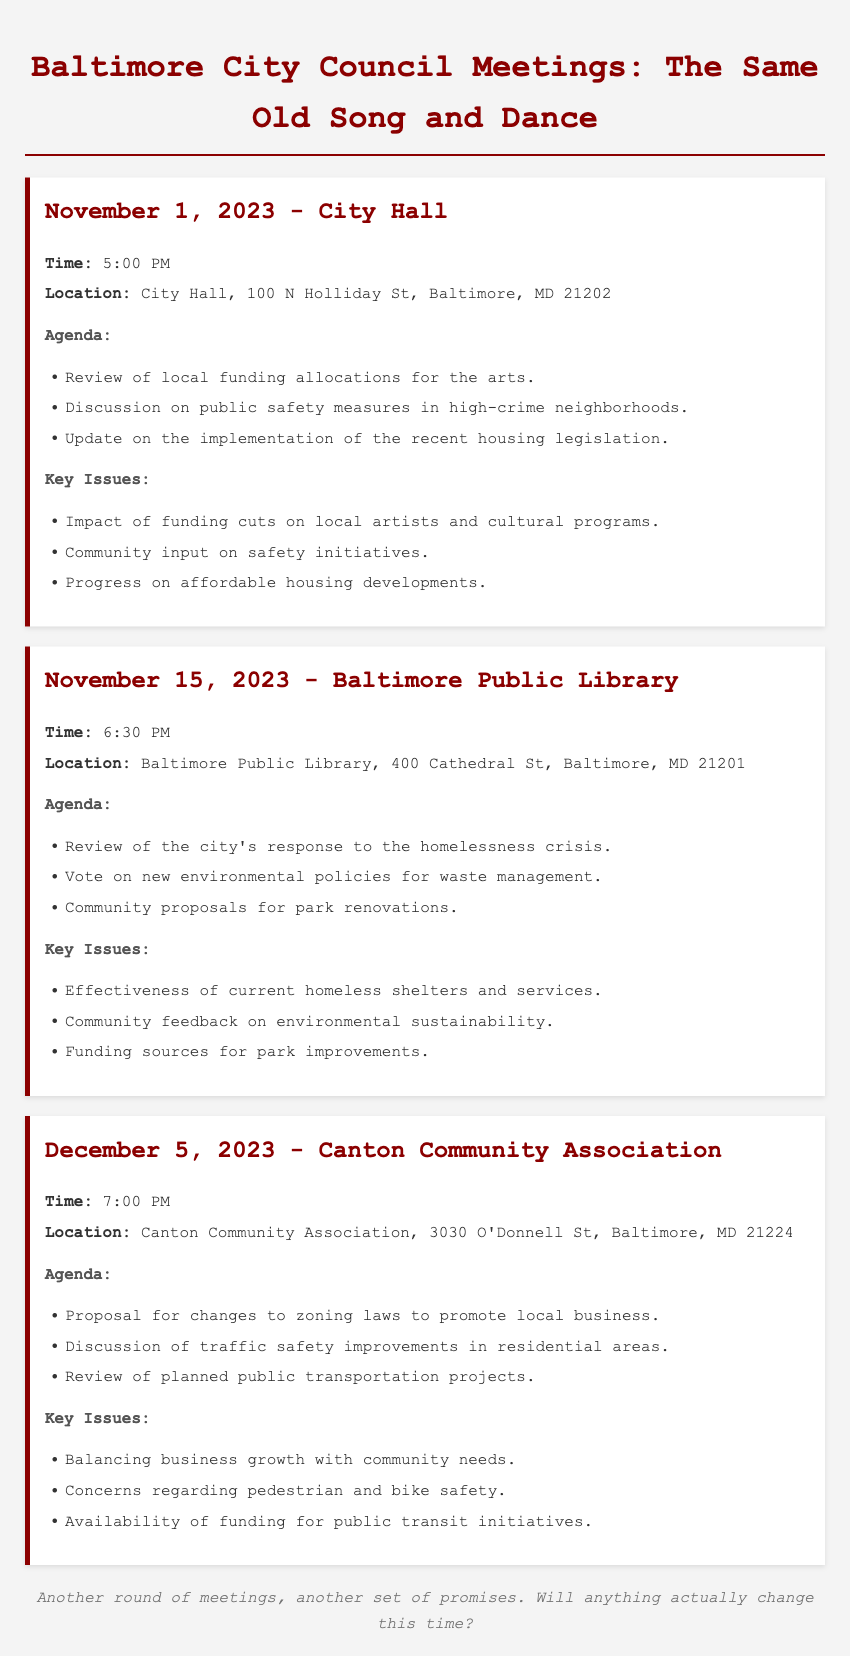What is the date of the first meeting? The first meeting is scheduled for November 1, 2023.
Answer: November 1, 2023 Where is the second meeting taking place? The second meeting will be held at the Baltimore Public Library.
Answer: Baltimore Public Library What time does the December 5, 2023, meeting start? The meeting on December 5, 2023, begins at 7:00 PM.
Answer: 7:00 PM What is one key issue discussed on November 1, 2023? One of the key issues is the impact of funding cuts on local artists and cultural programs.
Answer: Impact of funding cuts on local artists and cultural programs Which meeting addresses environmental policies? The meeting on November 15, 2023, addresses new environmental policies for waste management.
Answer: November 15, 2023 What is a proposal discussed on December 5, 2023? A proposal for changes to zoning laws to promote local business is discussed.
Answer: Changes to zoning laws to promote local business How many meetings are listed in the document? There are three meetings listed in the document.
Answer: Three What common theme appears in the agendas of the meetings? The agendas commonly focus on community issues and public welfare.
Answer: Community issues and public welfare 